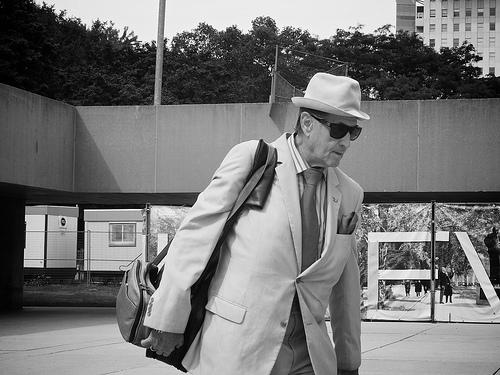Question: where was the picture taken?
Choices:
A. On a mountain.
B. At the zoo.
C. On a farm.
D. In a parking lot.
Answer with the letter. Answer: D Question: who is wearing a hat?
Choices:
A. A woman.
B. A child.
C. A man.
D. A baby.
Answer with the letter. Answer: C Question: how many people are in the picture?
Choices:
A. Three.
B. Four.
C. One.
D. Two.
Answer with the letter. Answer: C Question: what is over a man's shoulder?
Choices:
A. A baseball bat.
B. A bag.
C. A stick.
D. A jacket.
Answer with the letter. Answer: B Question: what is in the background?
Choices:
A. Playground.
B. A building.
C. Spaceship.
D. Train.
Answer with the letter. Answer: B Question: who is wearing a suit and tie?
Choices:
A. Man.
B. Woman.
C. Cat.
D. Dog.
Answer with the letter. Answer: A 